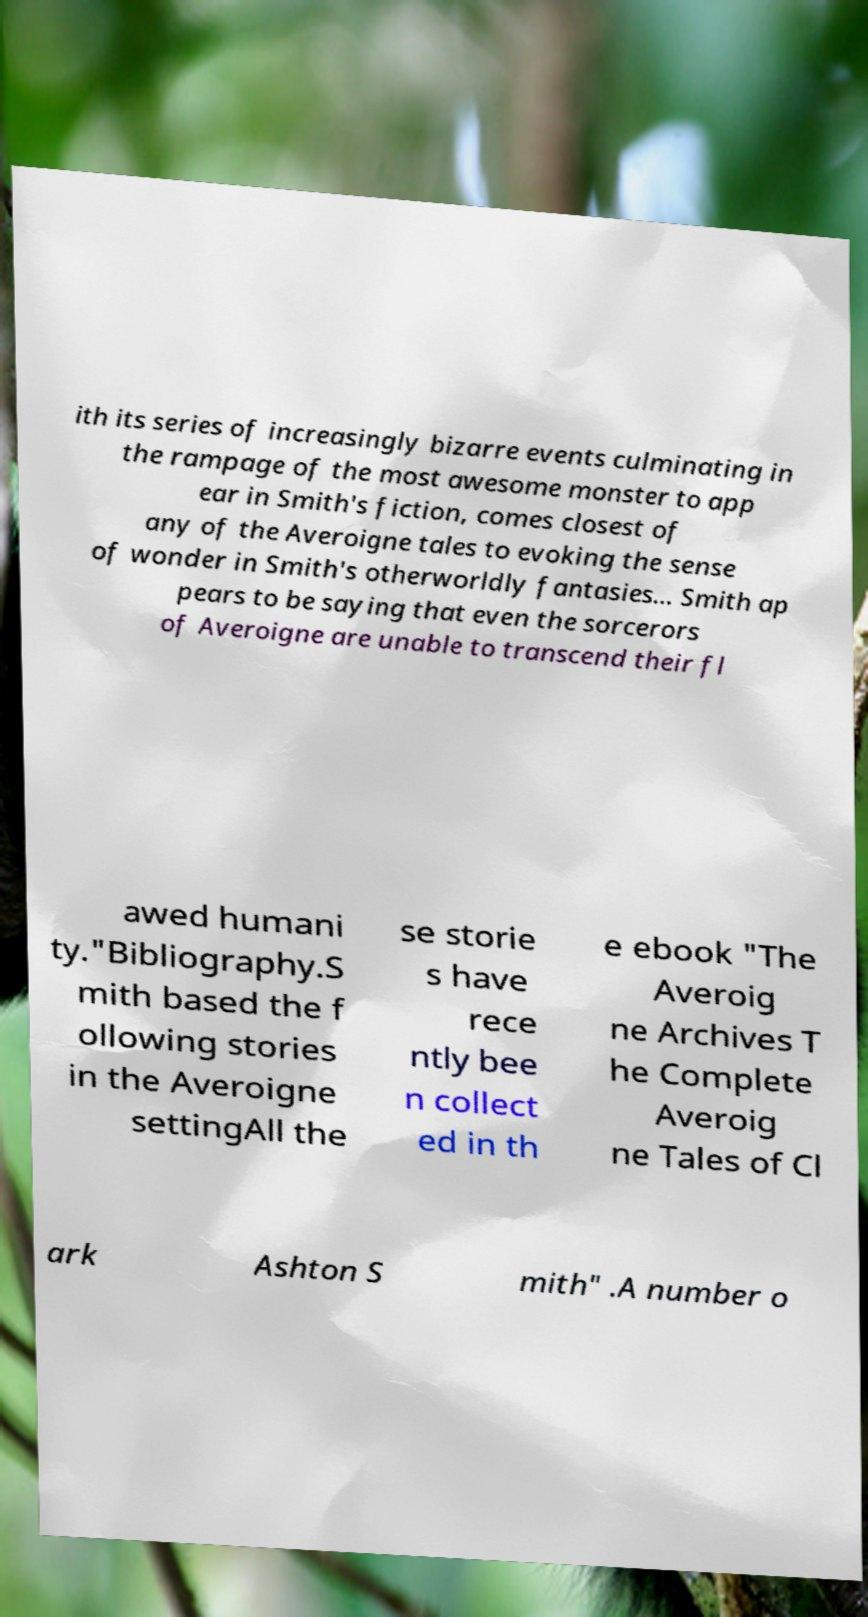I need the written content from this picture converted into text. Can you do that? ith its series of increasingly bizarre events culminating in the rampage of the most awesome monster to app ear in Smith's fiction, comes closest of any of the Averoigne tales to evoking the sense of wonder in Smith's otherworldly fantasies... Smith ap pears to be saying that even the sorcerors of Averoigne are unable to transcend their fl awed humani ty."Bibliography.S mith based the f ollowing stories in the Averoigne settingAll the se storie s have rece ntly bee n collect ed in th e ebook "The Averoig ne Archives T he Complete Averoig ne Tales of Cl ark Ashton S mith" .A number o 